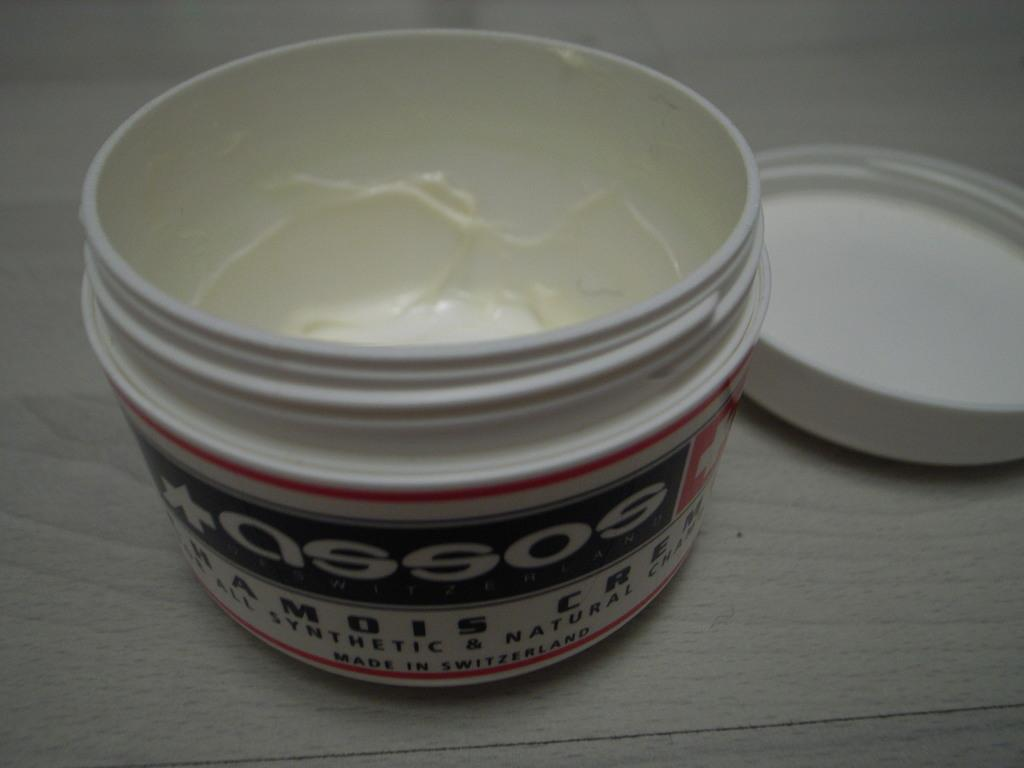<image>
Relay a brief, clear account of the picture shown. open white jar of assos and lid on a wooden shelf 